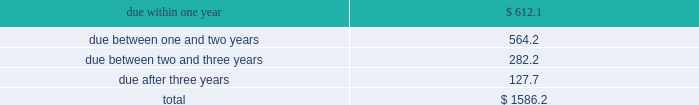Table of contents totaled an absolute notional equivalent of $ 292.3 million and $ 190.5 million , respectively , with the year-over-year increase primarily driven by earnings growth .
At this time , we do not hedge these long-term investment exposures .
We do not use foreign exchange contracts for speculative trading purposes , nor do we hedge our foreign currency exposure in a manner that entirely offsets the effects of changes in foreign exchange rates .
We regularly review our hedging program and assess the need to utilize financial instruments to hedge currency exposures on an ongoing basis .
Cash flow hedging 2014hedges of forecasted foreign currency revenue we may use foreign exchange purchased options or forward contracts to hedge foreign currency revenue denominated in euros , british pounds and japanese yen .
We hedge these cash flow exposures to reduce the risk that our earnings and cash flows will be adversely affected by changes in exchange rates .
These foreign exchange contracts , carried at fair value , may have maturities between one and twelve months .
We enter into these foreign exchange contracts to hedge forecasted revenue in the normal course of business and accordingly , they are not speculative in nature .
We record changes in the intrinsic value of these cash flow hedges in accumulated other comprehensive income ( loss ) until the forecasted transaction occurs .
When the forecasted transaction occurs , we reclassify the related gain or loss on the cash flow hedge to revenue .
In the event the underlying forecasted transaction does not occur , or it becomes probable that it will not occur , we reclassify the gain or loss on the related cash flow hedge from accumulated other comprehensive income ( loss ) to interest and other income , net on our consolidated statements of income at that time .
For the fiscal year ended november 30 , 2018 , there were no net gains or losses recognized in other income relating to hedges of forecasted transactions that did not occur .
Balance sheet hedging 2014hedging of foreign currency assets and liabilities we hedge exposures related to our net recognized foreign currency assets and liabilities with foreign exchange forward contracts to reduce the risk that our earnings and cash flows will be adversely affected by changes in foreign currency exchange rates .
These foreign exchange contracts are carried at fair value with changes in the fair value recorded as interest and other income , net .
These foreign exchange contracts do not subject us to material balance sheet risk due to exchange rate movements because gains and losses on these contracts are intended to offset gains and losses on the assets and liabilities being hedged .
At november 30 , 2018 , the outstanding balance sheet hedging derivatives had maturities of 180 days or less .
See note 5 of our notes to consolidated financial statements for information regarding our hedging activities .
Interest rate risk short-term investments and fixed income securities at november 30 , 2018 , we had debt securities classified as short-term investments of $ 1.59 billion .
Changes in interest rates could adversely affect the market value of these investments .
The table separates these investments , based on stated maturities , to show the approximate exposure to interest rates ( in millions ) : .
A sensitivity analysis was performed on our investment portfolio as of november 30 , 2018 .
The analysis is based on an estimate of the hypothetical changes in market value of the portfolio that would result from an immediate parallel shift in the yield curve of various magnitudes. .
Of the short-term investments and fixed income securities at november 30 , 2018 , what percentage are due after three years? 
Computations: (127.7 / 1586.2)
Answer: 0.08051. 